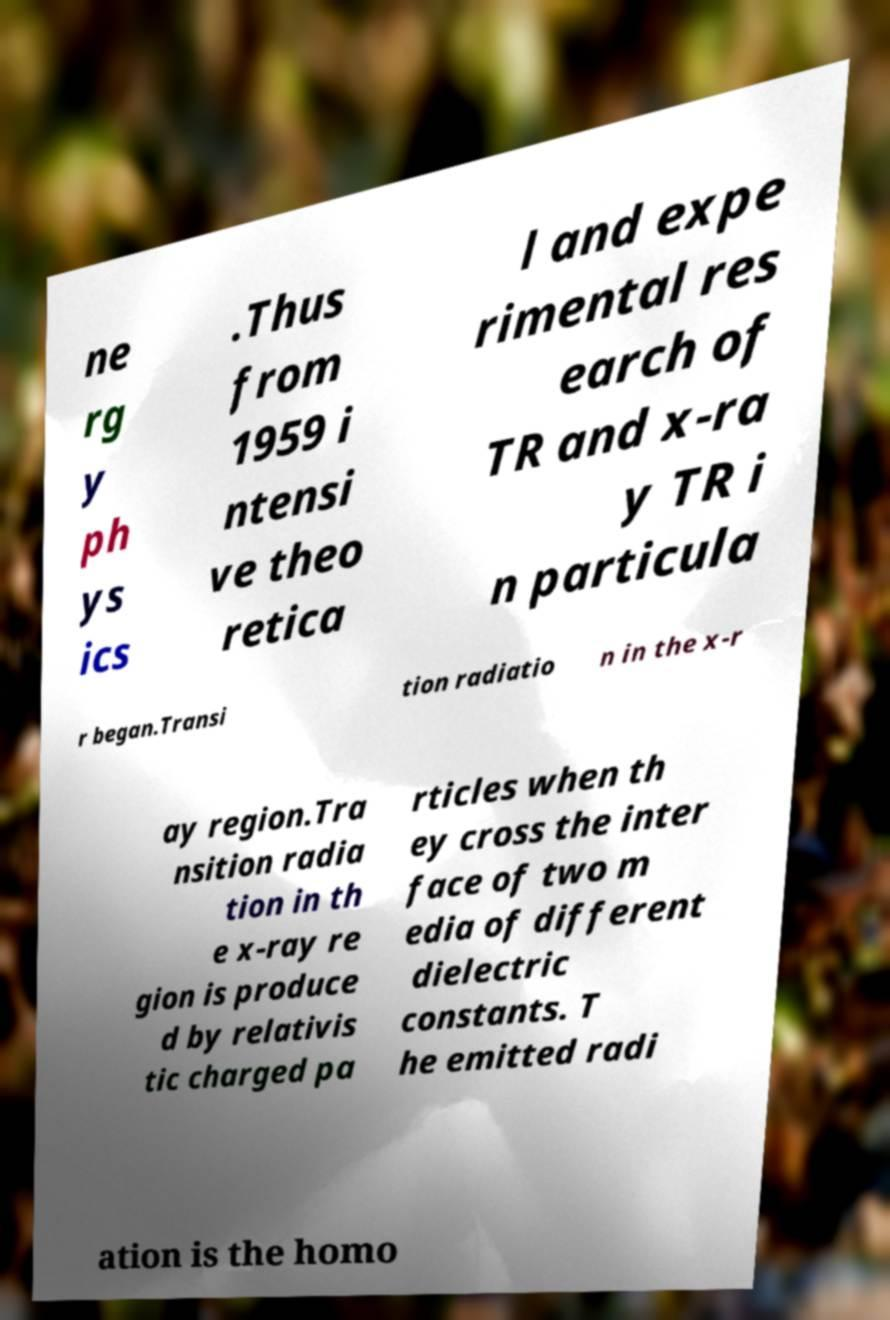Can you read and provide the text displayed in the image?This photo seems to have some interesting text. Can you extract and type it out for me? ne rg y ph ys ics .Thus from 1959 i ntensi ve theo retica l and expe rimental res earch of TR and x-ra y TR i n particula r began.Transi tion radiatio n in the x-r ay region.Tra nsition radia tion in th e x-ray re gion is produce d by relativis tic charged pa rticles when th ey cross the inter face of two m edia of different dielectric constants. T he emitted radi ation is the homo 